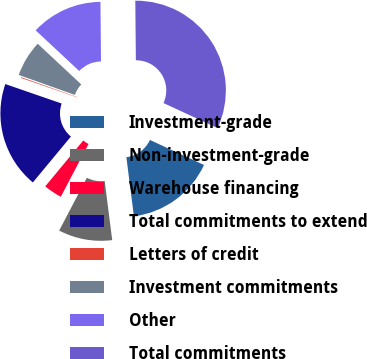<chart> <loc_0><loc_0><loc_500><loc_500><pie_chart><fcel>Investment-grade<fcel>Non-investment-grade<fcel>Warehouse financing<fcel>Total commitments to extend<fcel>Letters of credit<fcel>Investment commitments<fcel>Other<fcel>Total commitments<nl><fcel>16.09%<fcel>9.71%<fcel>3.33%<fcel>19.28%<fcel>0.14%<fcel>6.52%<fcel>12.9%<fcel>32.04%<nl></chart> 